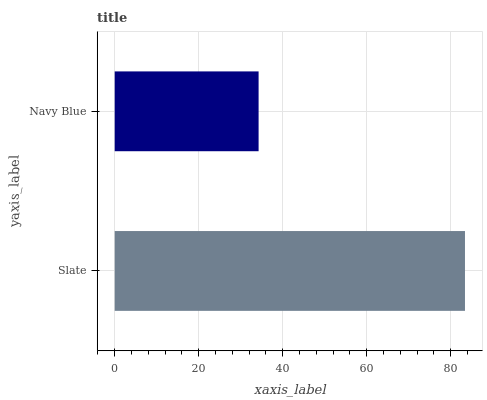Is Navy Blue the minimum?
Answer yes or no. Yes. Is Slate the maximum?
Answer yes or no. Yes. Is Navy Blue the maximum?
Answer yes or no. No. Is Slate greater than Navy Blue?
Answer yes or no. Yes. Is Navy Blue less than Slate?
Answer yes or no. Yes. Is Navy Blue greater than Slate?
Answer yes or no. No. Is Slate less than Navy Blue?
Answer yes or no. No. Is Slate the high median?
Answer yes or no. Yes. Is Navy Blue the low median?
Answer yes or no. Yes. Is Navy Blue the high median?
Answer yes or no. No. Is Slate the low median?
Answer yes or no. No. 